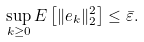<formula> <loc_0><loc_0><loc_500><loc_500>\sup _ { k \geq 0 } E \left [ \| e _ { k } \| _ { 2 } ^ { 2 } \right ] \leq \bar { \varepsilon } .</formula> 